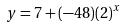Convert formula to latex. <formula><loc_0><loc_0><loc_500><loc_500>y = 7 + ( - 4 8 ) ( 2 ) ^ { x }</formula> 